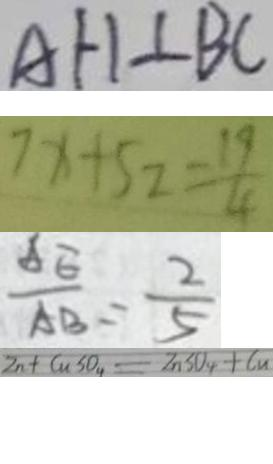<formula> <loc_0><loc_0><loc_500><loc_500>A H \bot B C 
 7 x + 5 2 = \frac { 1 9 } { 4 } 
 \frac { A E } { A B } = \frac { 2 } { 5 } 
 Z n + C u S O _ { 4 } = Z n S O _ { 4 } + C u</formula> 